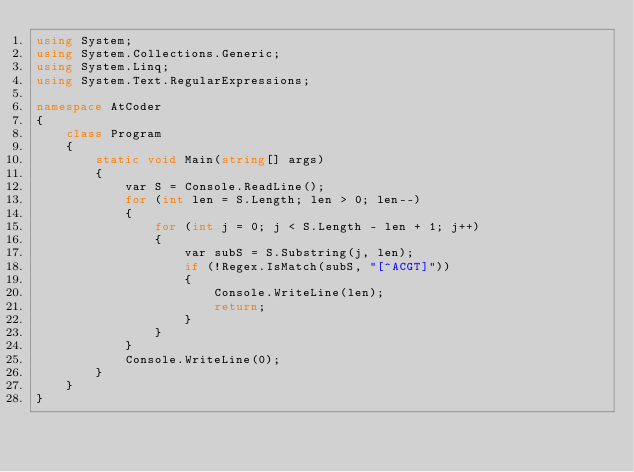<code> <loc_0><loc_0><loc_500><loc_500><_C#_>using System;
using System.Collections.Generic;
using System.Linq;
using System.Text.RegularExpressions;

namespace AtCoder
{
    class Program
    {
        static void Main(string[] args)
        {
            var S = Console.ReadLine();
            for (int len = S.Length; len > 0; len--)
            {
                for (int j = 0; j < S.Length - len + 1; j++)
                {
                    var subS = S.Substring(j, len);
                    if (!Regex.IsMatch(subS, "[^ACGT]"))
                    {
                        Console.WriteLine(len);
                        return;
                    }
                }
            }
            Console.WriteLine(0);
        }
    }
}
</code> 